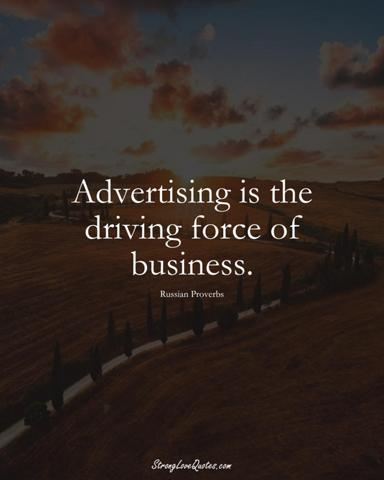How does the imagery of the tranquil countryside relate to the idea of advertising as a business driver? The serene countryside in the image, with its open roads stretching into the horizon, serves as a metaphor for the journey businesses undertake. Advertising can be likened to the decisive momentum on these roads, propelling a business forward. The vast skies suggest the limitless possibilities that good advertising can open up, while the fenced fields imply the structured approach required in advertisement planning and execution. Together, these elements encapsulate the balance between the methodical aspects of business strategy and the creative, boundless potential of advertising. 